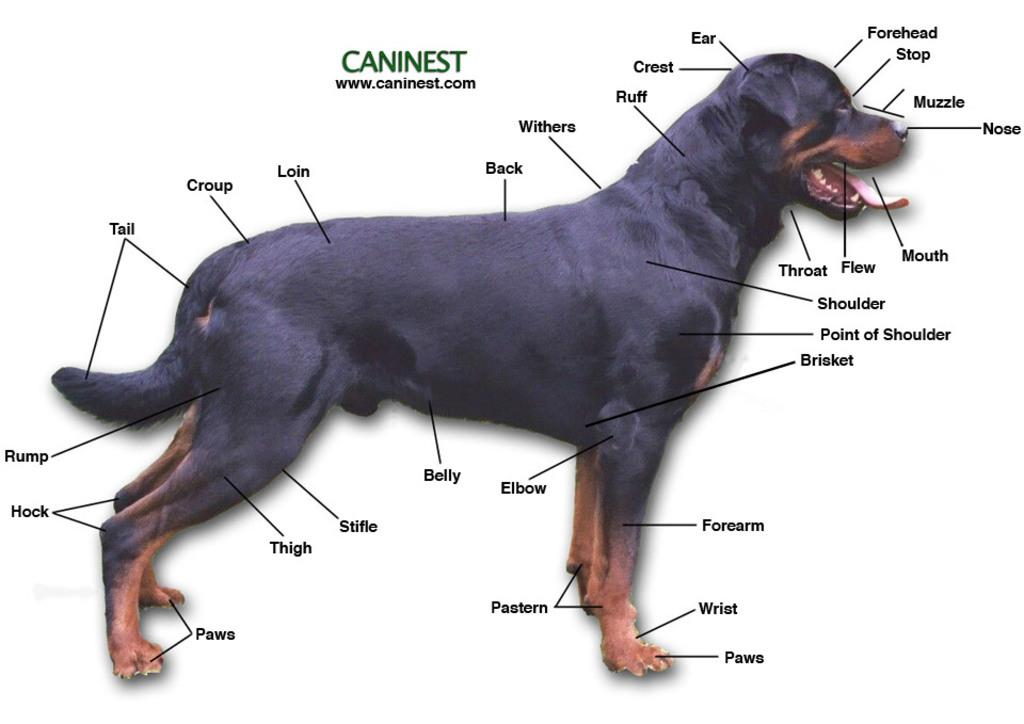What type of animal is featured in the image? There is a picture of a black color dog in the image. Can you describe any additional elements in the image? There is some text written in the background of the image. How many teeth can be seen in the image? There are no teeth visible in the image, as it features a picture of a dog and dogs do not have visible teeth in this context. 